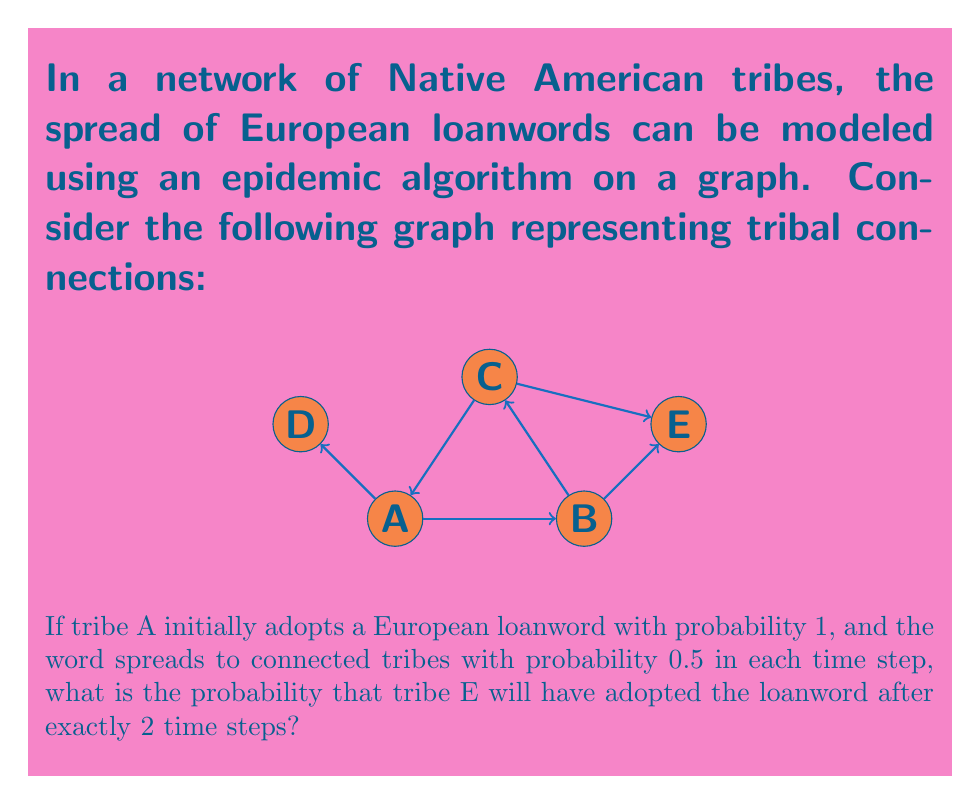What is the answer to this math problem? Let's approach this step-by-step:

1) First, we need to identify all possible paths from A to E that take exactly 2 steps:
   Path 1: A → B → E
   Path 2: A → C → E

2) For each path, we calculate the probability of the word spreading along that path:

   Path 1: P(A → B → E) = 1 * 0.5 * 0.5 = 0.25
   Path 2: P(A → C → E) = 1 * 0.5 * 0.5 = 0.25

3) The probability that E adopts the word is the probability that at least one of these paths succeeds. To calculate this, we use the complement of the probability that both paths fail:

   P(E adopts) = 1 - P(neither path succeeds)
                = 1 - P(Path 1 fails AND Path 2 fails)
                = 1 - (1 - 0.25) * (1 - 0.25)
                = 1 - 0.75 * 0.75
                = 1 - 0.5625
                = 0.4375

Therefore, the probability that tribe E will have adopted the loanword after exactly 2 time steps is 0.4375 or 43.75%.
Answer: 0.4375 